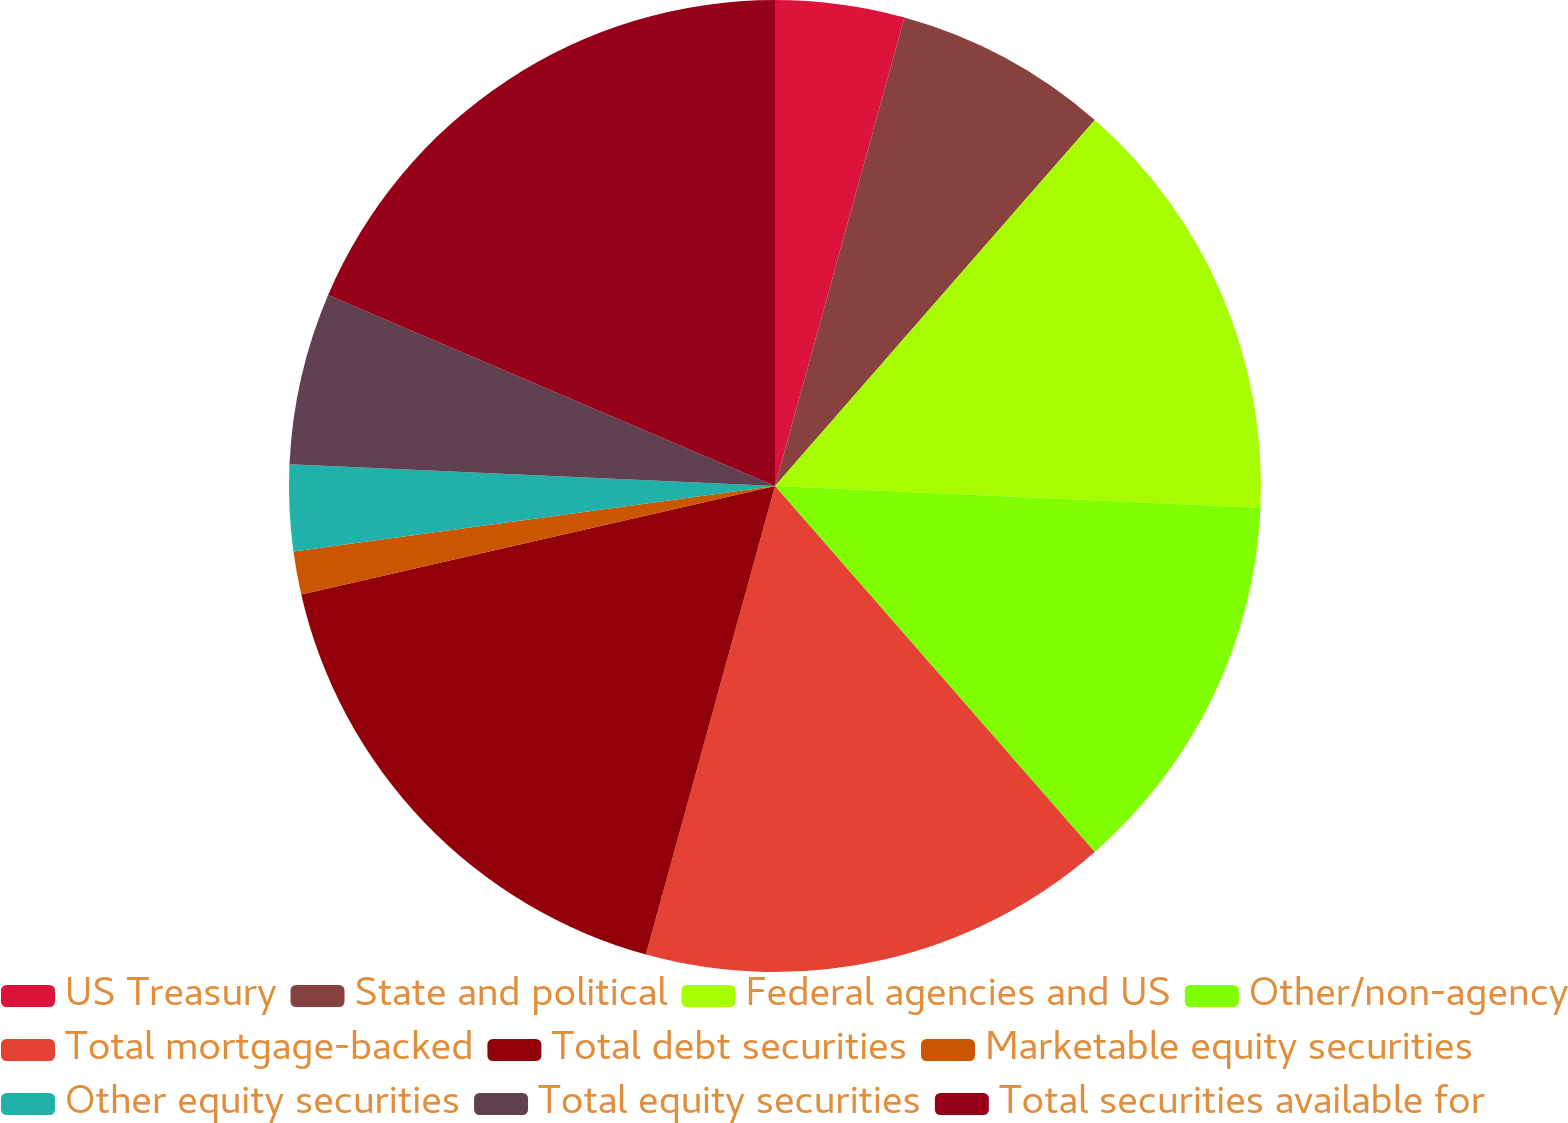Convert chart. <chart><loc_0><loc_0><loc_500><loc_500><pie_chart><fcel>US Treasury<fcel>State and political<fcel>Federal agencies and US<fcel>Other/non-agency<fcel>Total mortgage-backed<fcel>Total debt securities<fcel>Marketable equity securities<fcel>Other equity securities<fcel>Total equity securities<fcel>Total securities available for<nl><fcel>4.29%<fcel>7.14%<fcel>14.28%<fcel>12.86%<fcel>15.71%<fcel>17.14%<fcel>1.43%<fcel>2.86%<fcel>5.72%<fcel>18.57%<nl></chart> 